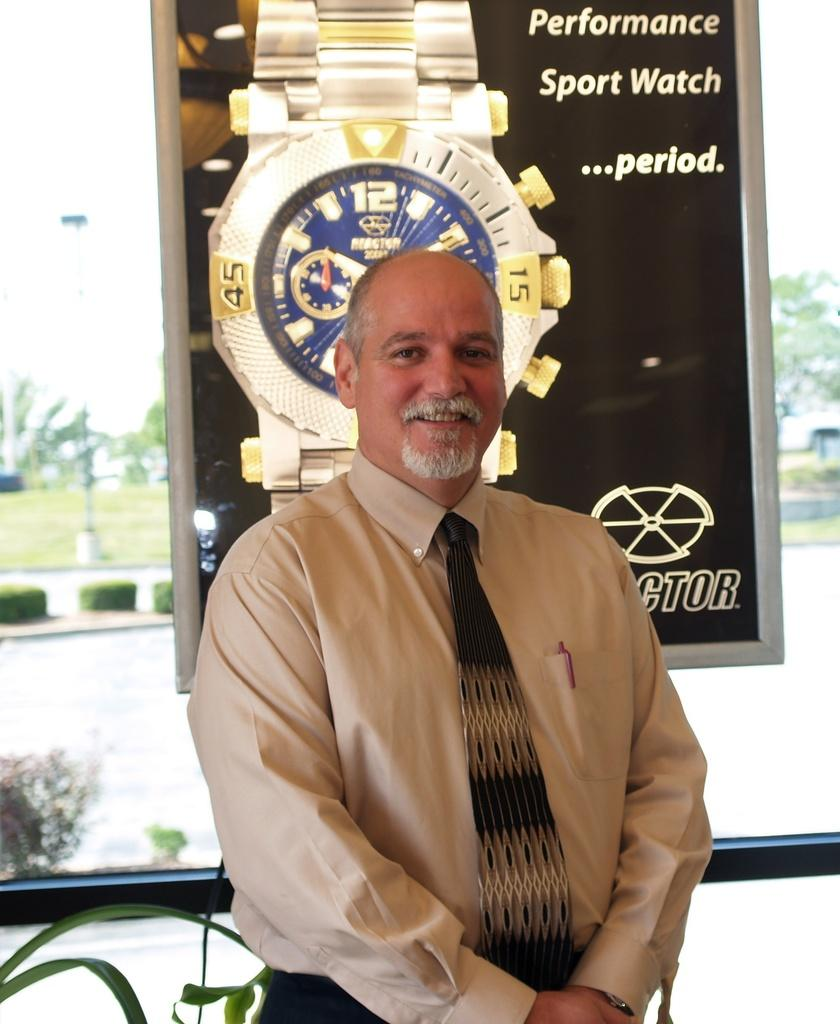<image>
Share a concise interpretation of the image provided. Man standing in front of a sign that says "Performance Sport Watch". 